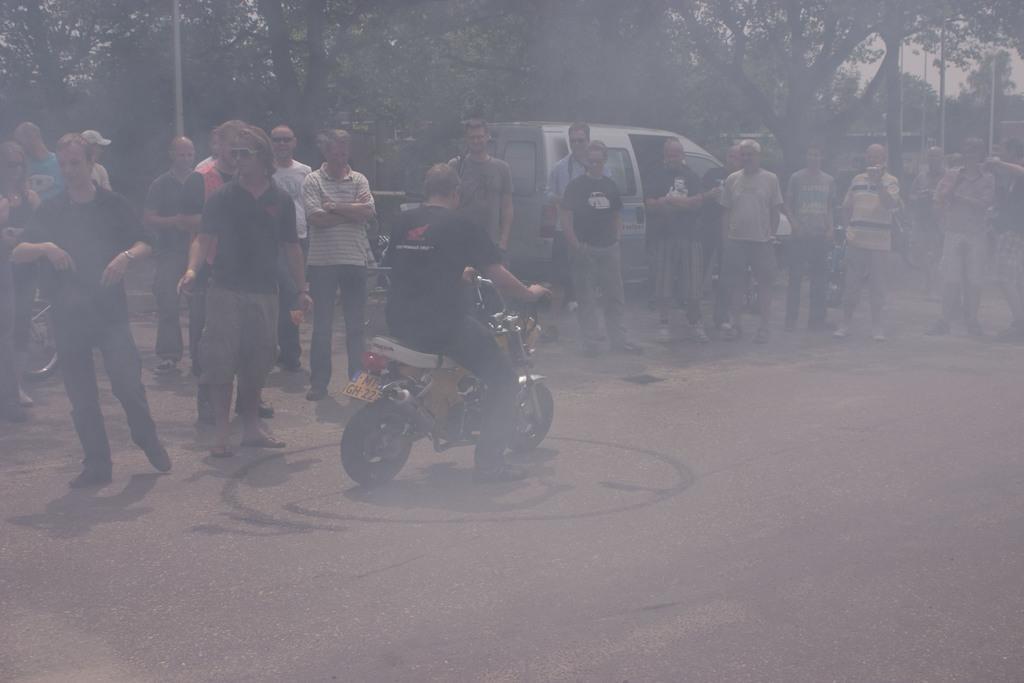Describe this image in one or two sentences. In this picture there is a man sitting on the bike and riding it on the road. There are some people standing and watching. There is a smoke. And in the background there are some trees, pole and a car here. 